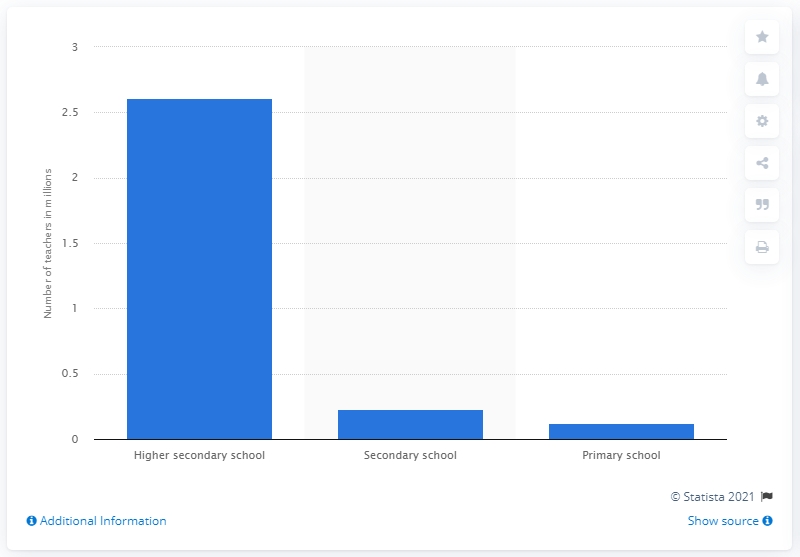Highlight a few significant elements in this photo. In 2014, there were approximately 2.61 million primary school teachers in India. 